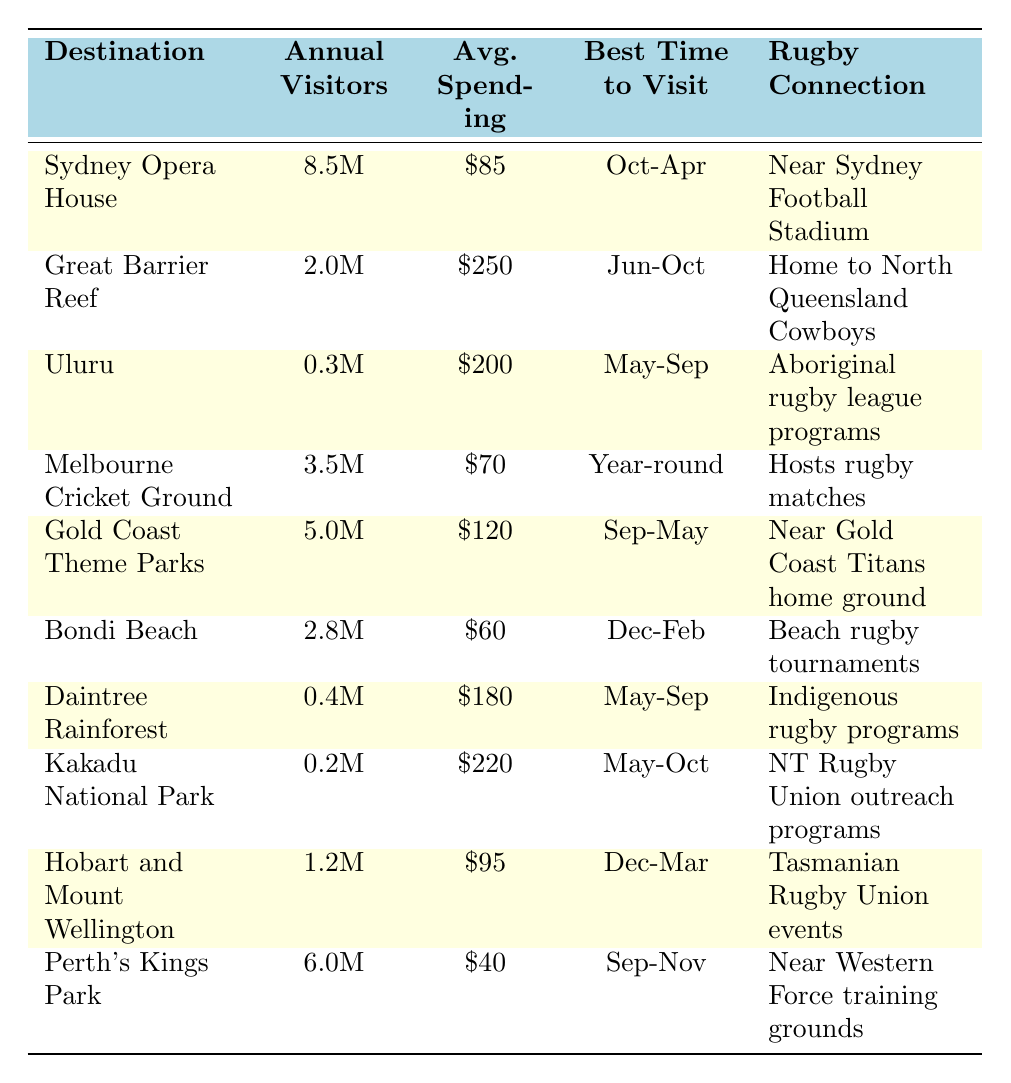What is the annual visitor count for the Great Barrier Reef? The table lists the annual visitors for the Great Barrier Reef as 2.0 million.
Answer: 2.0 million Which destination has the highest average spending per visitor? The table shows that the Great Barrier Reef has the highest average spending per visitor at $250.
Answer: Great Barrier Reef What is the average annual visitor count for destinations in Queensland? The annual visitor counts for Queensland destinations are 2.0M (Great Barrier Reef), 5.0M (Gold Coast Theme Parks), and 0.4M (Daintree Rainforest). Summing these gives 7.4 million visitors. Dividing by 3 gives an average of about 2.47 million visitors.
Answer: 2.47 million Is the Melbourne Cricket Ground popular year-round? The table indicates that the best time to visit the Melbourne Cricket Ground is year-round, confirming its popularity.
Answer: Yes Which destination should you visit for the best sunrise viewing experience? According to the table, Uluru is known for sunrise viewing as its popular activity.
Answer: Uluru What is the combined average spending for visitors of Bondi Beach and Daintree Rainforest? The average spending for Bondi Beach is $60 and for Daintree Rainforest it is $180. Adding these gives $240, and the total number of visitors is 2.8M + 0.4M = 3.2M. The combined average spending is $240 / 2 = $120.
Answer: $120 Are there any destinations with less than 1 million annual visitors? The table shows both Kakadu National Park (200,000) and Uluru (300,000) have less than 1 million visitors annually.
Answer: Yes What is the difference in average spending between the Gold Coast Theme Parks and Perth's Kings Park? The Gold Coast Theme Parks has an average spending of $120 while Perth's Kings Park has $40. The difference is $120 - $40 = $80.
Answer: $80 Which destination has a rugby connection related to the Western Force? The table indicates that Perth's Kings Park is near the Western Force training grounds, establishing its rugby connection.
Answer: Perth's Kings Park What is the best time to visit Hobart and Mount Wellington? The best time to visit Hobart and Mount Wellington is listed in the table as December to March.
Answer: December to March 